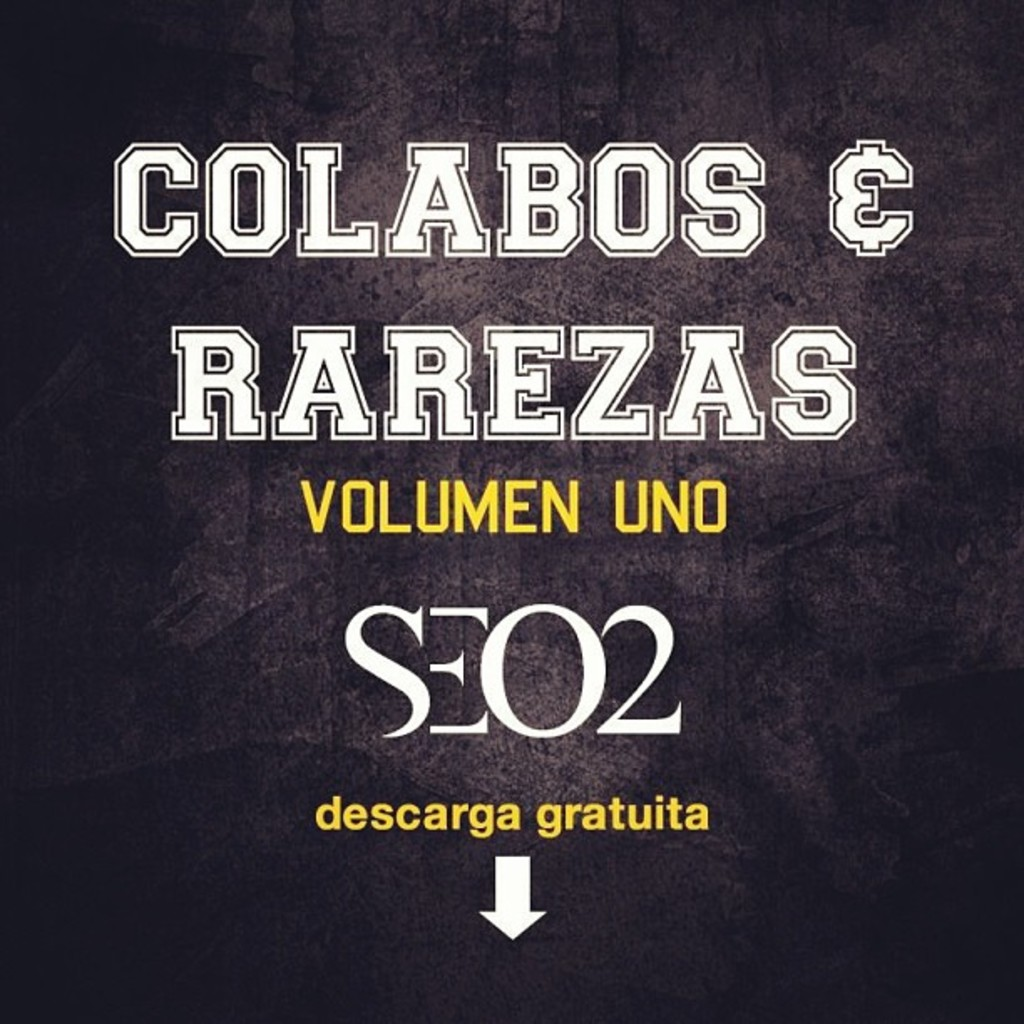What kind of music can we expect from this album? Based on the album title and the artist SEO2, one might expect a mix of collaborations and rare tracks in this collection. It's likely to showcase a varied music style including hip-hop, as SEO2 is known for this genre. The 'Volumen Uno' suggests there could be more volumes to come, each potentially offering a unique blend of sounds and featuring different artists. 